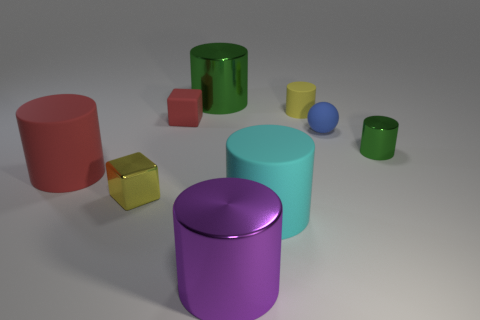Subtract all large cyan cylinders. How many cylinders are left? 5 Subtract all red cylinders. How many cylinders are left? 5 Subtract all brown cylinders. Subtract all gray cubes. How many cylinders are left? 6 Add 1 tiny things. How many objects exist? 10 Subtract all blocks. How many objects are left? 7 Add 4 large purple cylinders. How many large purple cylinders exist? 5 Subtract 0 yellow balls. How many objects are left? 9 Subtract all big cyan matte things. Subtract all tiny matte spheres. How many objects are left? 7 Add 2 small blue things. How many small blue things are left? 3 